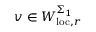<formula> <loc_0><loc_0><loc_500><loc_500>v \in W _ { l o c , r } ^ { \Sigma _ { 1 } }</formula> 